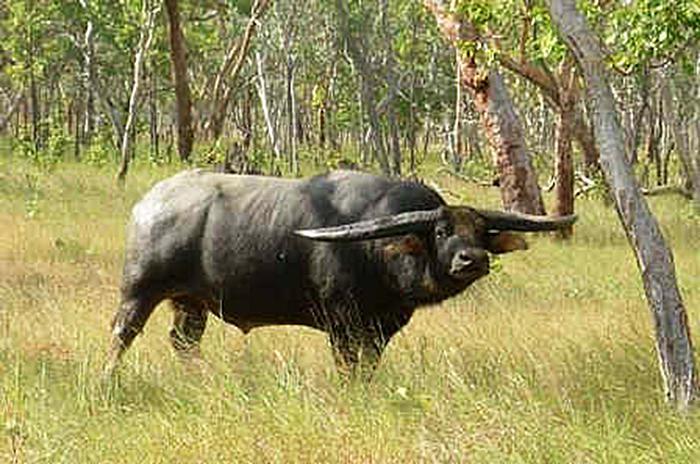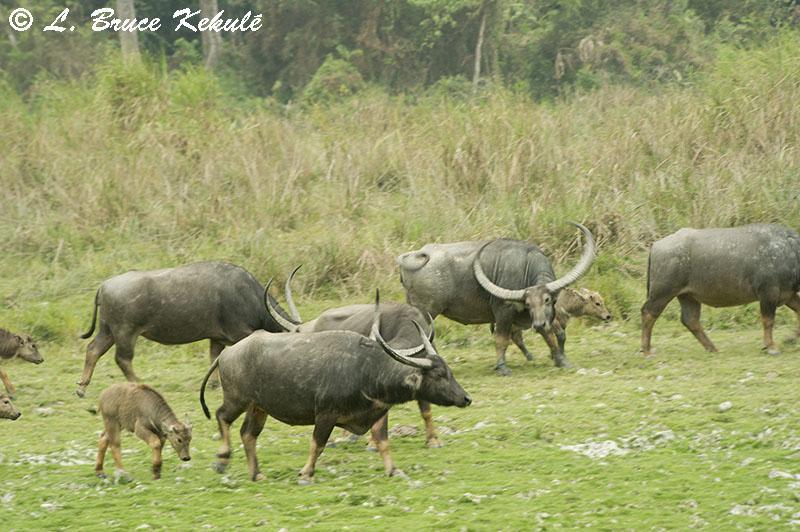The first image is the image on the left, the second image is the image on the right. Examine the images to the left and right. Is the description "Left image shows one water buffalo standing in profile, with body turned leftward." accurate? Answer yes or no. No. The first image is the image on the left, the second image is the image on the right. Analyze the images presented: Is the assertion "There are more animals in the image on the right than in the image on the left." valid? Answer yes or no. Yes. 